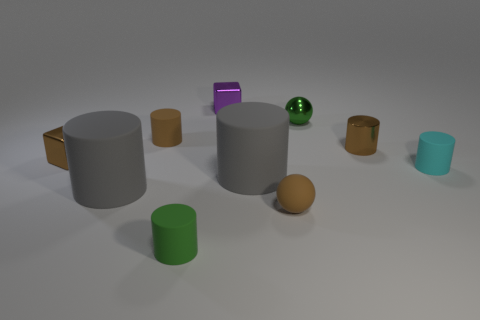Do the cyan cylinder and the tiny green thing that is in front of the tiny matte ball have the same material? yes 